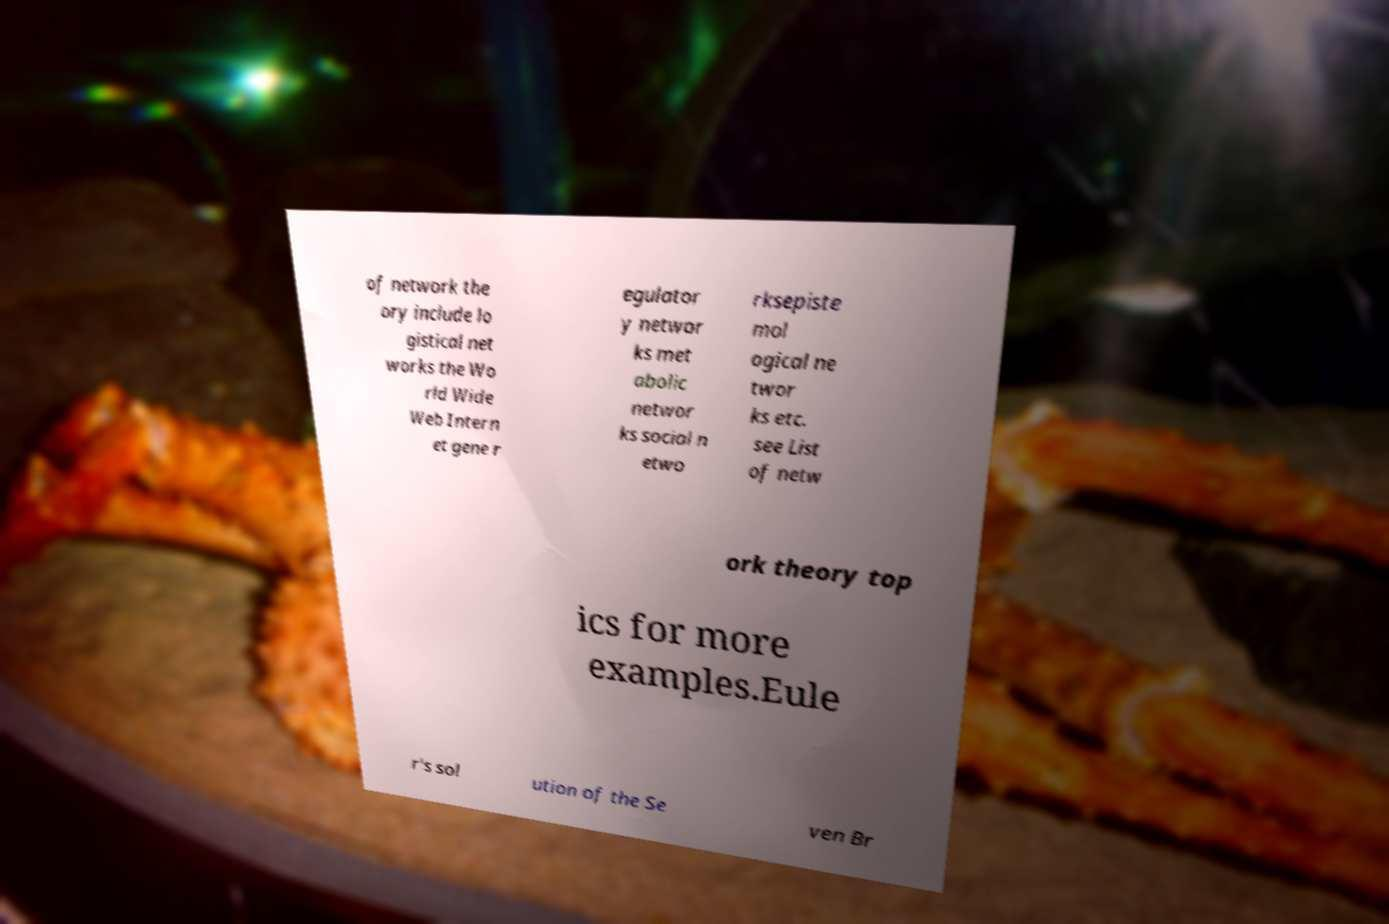For documentation purposes, I need the text within this image transcribed. Could you provide that? of network the ory include lo gistical net works the Wo rld Wide Web Intern et gene r egulator y networ ks met abolic networ ks social n etwo rksepiste mol ogical ne twor ks etc. see List of netw ork theory top ics for more examples.Eule r's sol ution of the Se ven Br 